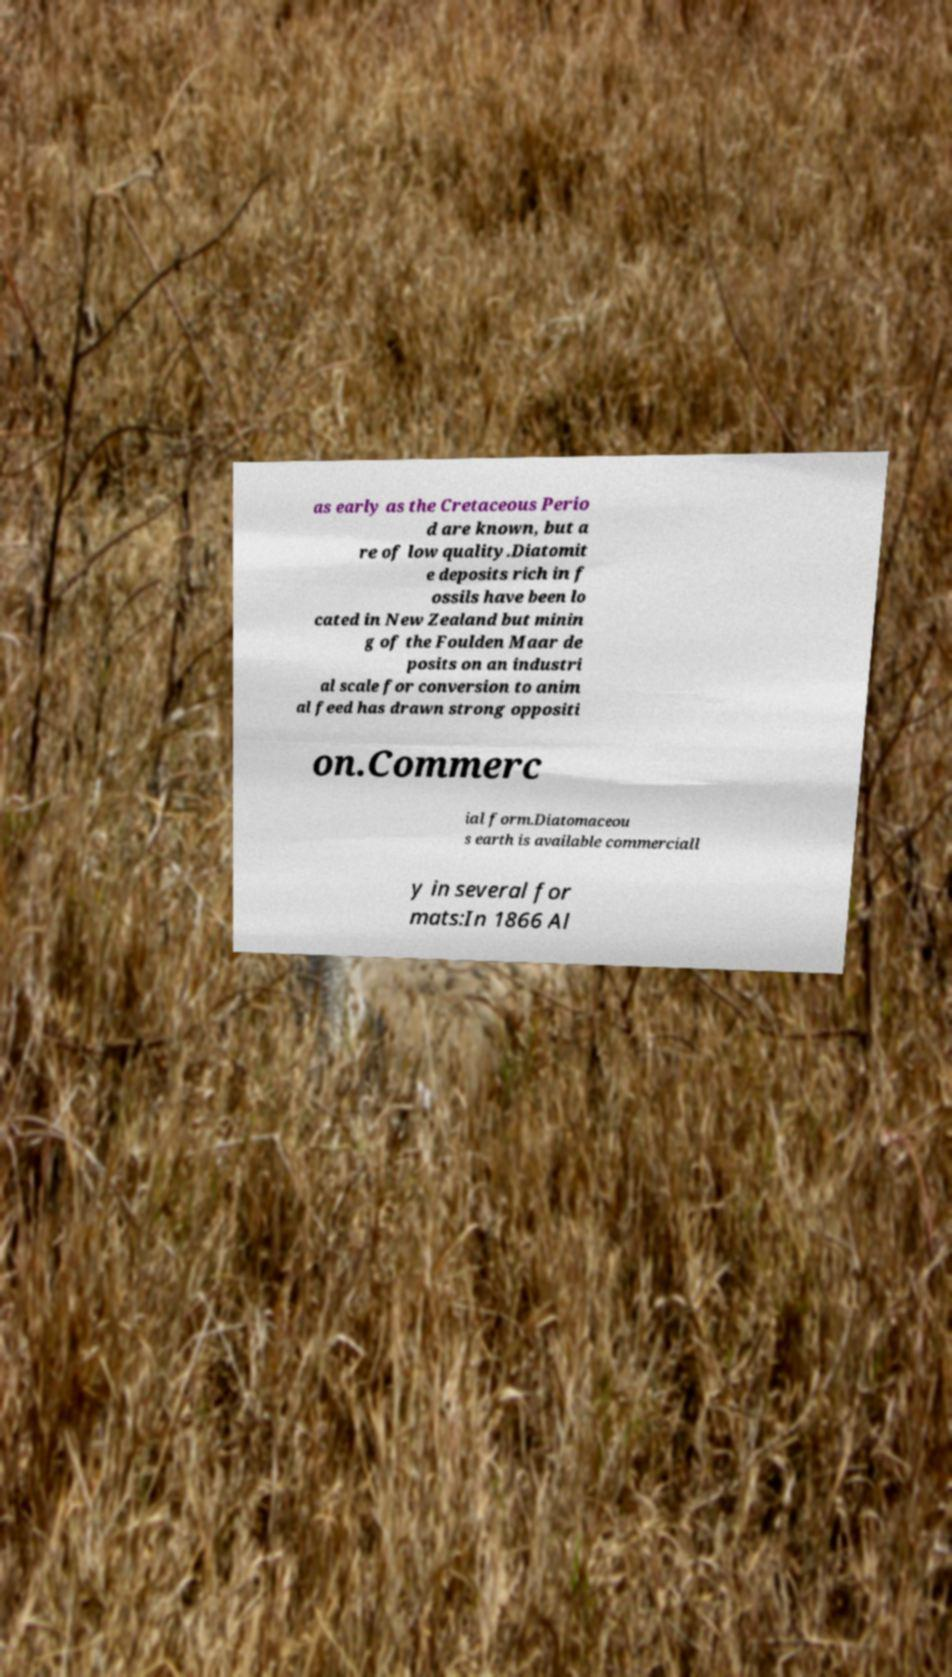Can you accurately transcribe the text from the provided image for me? as early as the Cretaceous Perio d are known, but a re of low quality.Diatomit e deposits rich in f ossils have been lo cated in New Zealand but minin g of the Foulden Maar de posits on an industri al scale for conversion to anim al feed has drawn strong oppositi on.Commerc ial form.Diatomaceou s earth is available commerciall y in several for mats:In 1866 Al 